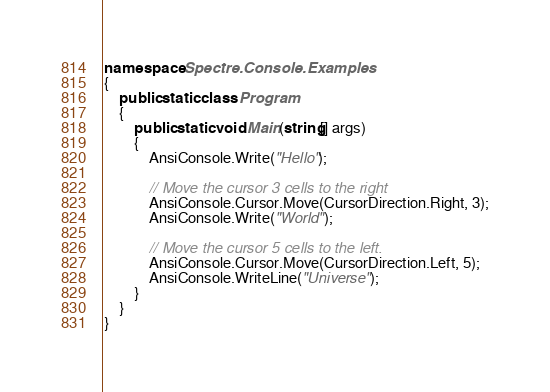<code> <loc_0><loc_0><loc_500><loc_500><_C#_>namespace Spectre.Console.Examples
{
    public static class Program
    {
        public static void Main(string[] args)
        {
            AnsiConsole.Write("Hello");

            // Move the cursor 3 cells to the right
            AnsiConsole.Cursor.Move(CursorDirection.Right, 3);
            AnsiConsole.Write("World");

            // Move the cursor 5 cells to the left.
            AnsiConsole.Cursor.Move(CursorDirection.Left, 5);
            AnsiConsole.WriteLine("Universe");
        }
    }
}
</code> 